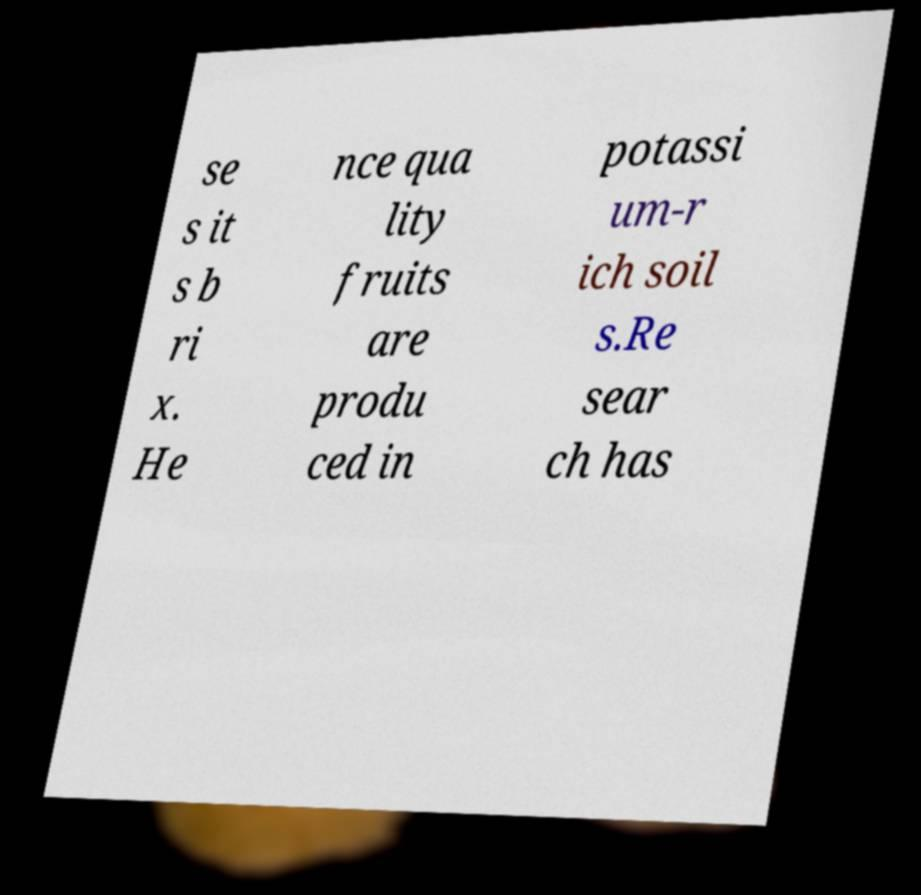Could you extract and type out the text from this image? se s it s b ri x. He nce qua lity fruits are produ ced in potassi um-r ich soil s.Re sear ch has 